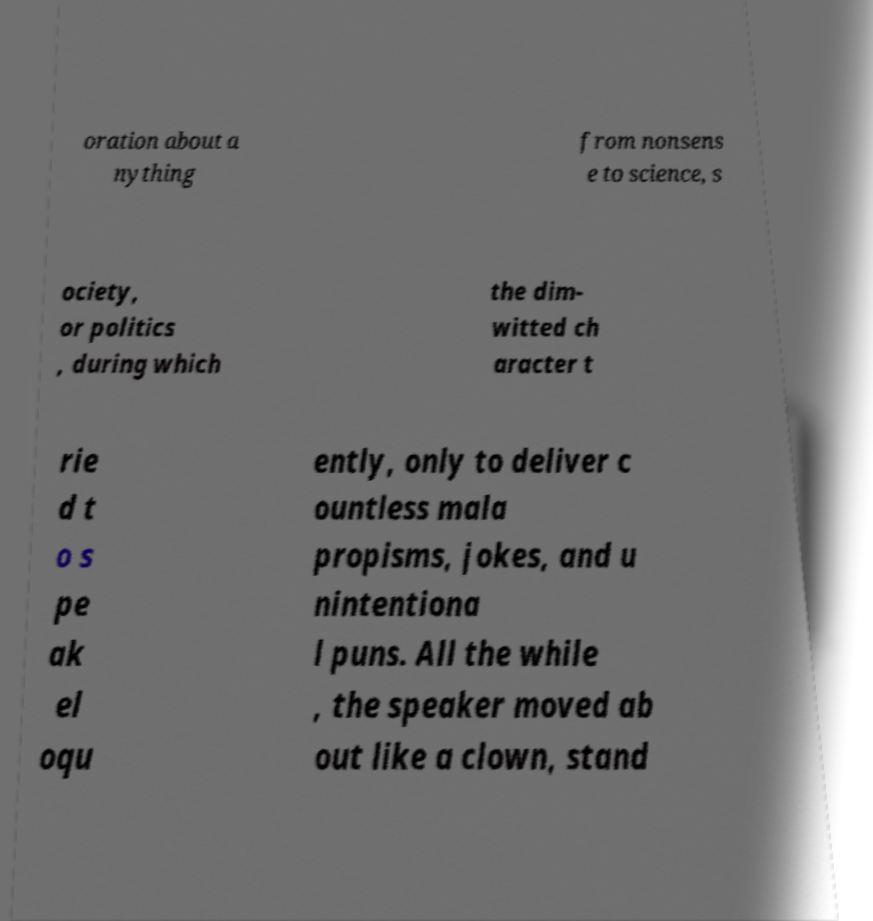Please read and relay the text visible in this image. What does it say? oration about a nything from nonsens e to science, s ociety, or politics , during which the dim- witted ch aracter t rie d t o s pe ak el oqu ently, only to deliver c ountless mala propisms, jokes, and u nintentiona l puns. All the while , the speaker moved ab out like a clown, stand 